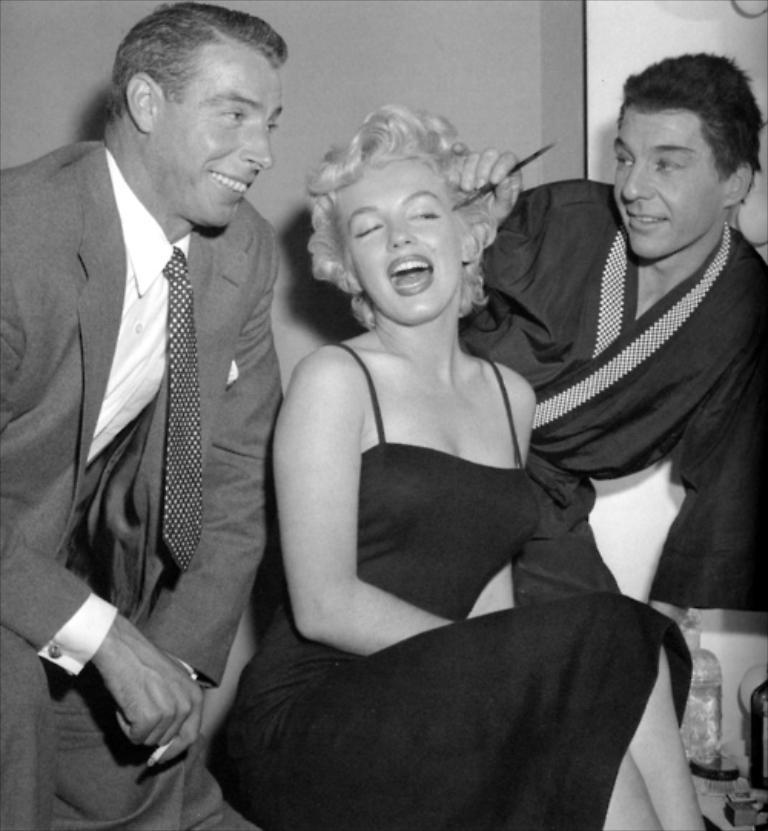What is the woman in the image doing? The beautiful woman is sitting in the image. What is the woman wearing? The woman is wearing a dress. Who else is present in the image? There is a man on the left side of the image. What is the man wearing? The man is wearing a coat, tie, and shirt. What is the man's expression in the image? The man is smiling. What type of oil can be seen dripping from the woman's hair in the image? There is no oil present in the image, and the woman's hair does not appear to be dripping with any substance. 